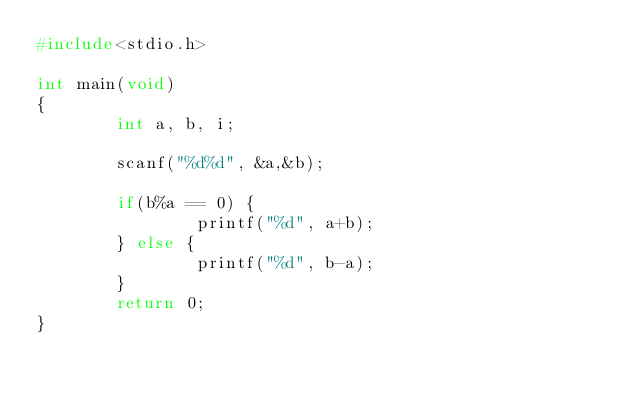<code> <loc_0><loc_0><loc_500><loc_500><_C_>#include<stdio.h>

int main(void)
{
        int a, b, i;

        scanf("%d%d", &a,&b);

        if(b%a == 0) {
                printf("%d", a+b);
        } else {
                printf("%d", b-a);
        }
        return 0;
}</code> 